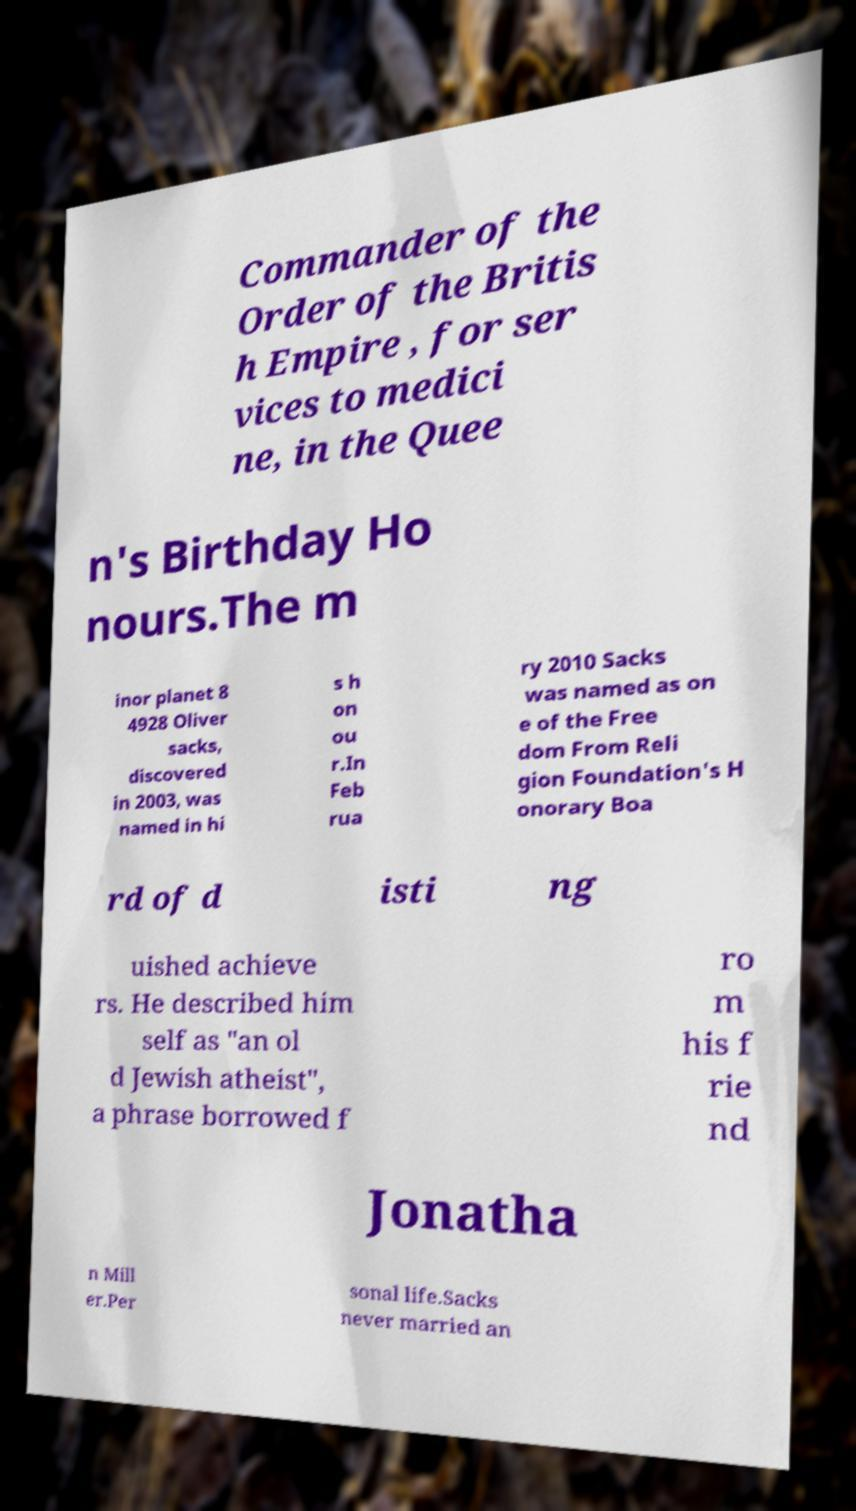Could you assist in decoding the text presented in this image and type it out clearly? Commander of the Order of the Britis h Empire , for ser vices to medici ne, in the Quee n's Birthday Ho nours.The m inor planet 8 4928 Oliver sacks, discovered in 2003, was named in hi s h on ou r.In Feb rua ry 2010 Sacks was named as on e of the Free dom From Reli gion Foundation's H onorary Boa rd of d isti ng uished achieve rs. He described him self as "an ol d Jewish atheist", a phrase borrowed f ro m his f rie nd Jonatha n Mill er.Per sonal life.Sacks never married an 